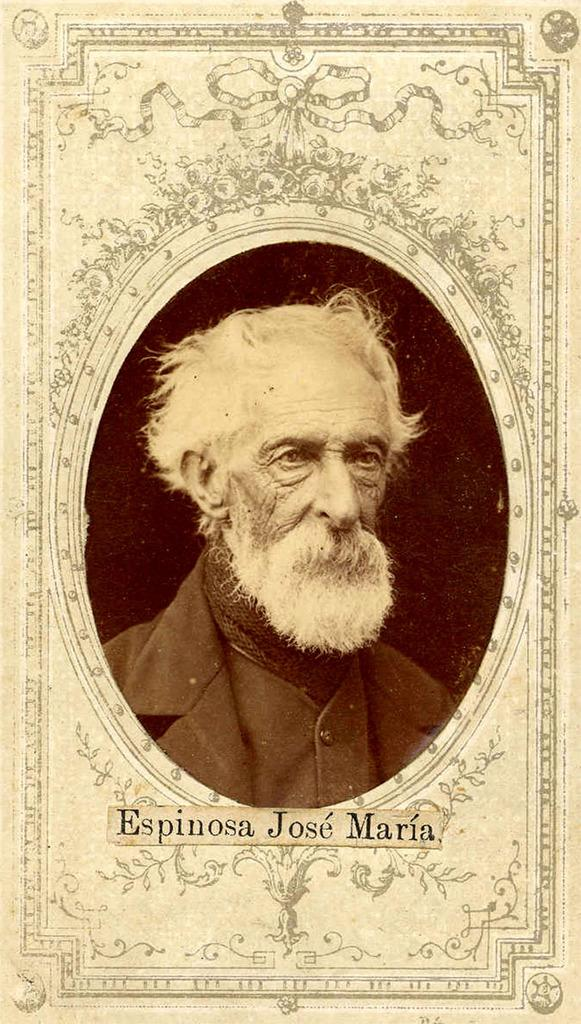What is the main subject of the image? There is a picture of a person in the image. Can you describe any additional details about the person's picture? There is text written at the bottom of the person's picture. How many cows are visible in the image? There are no cows present in the image. What country is the person from in the image? The country of origin for the person in the image is not mentioned or visible. 